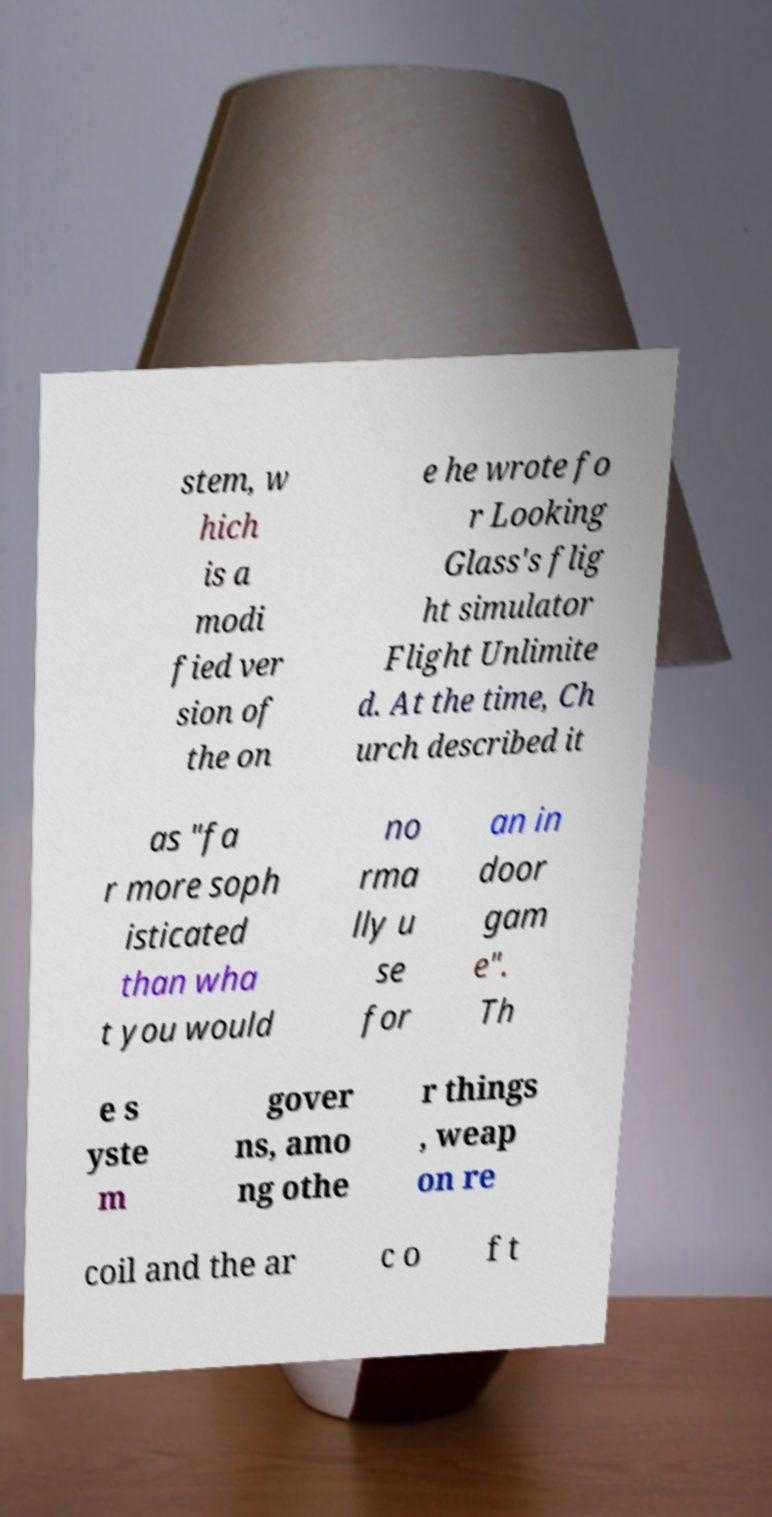There's text embedded in this image that I need extracted. Can you transcribe it verbatim? stem, w hich is a modi fied ver sion of the on e he wrote fo r Looking Glass's flig ht simulator Flight Unlimite d. At the time, Ch urch described it as "fa r more soph isticated than wha t you would no rma lly u se for an in door gam e". Th e s yste m gover ns, amo ng othe r things , weap on re coil and the ar c o f t 